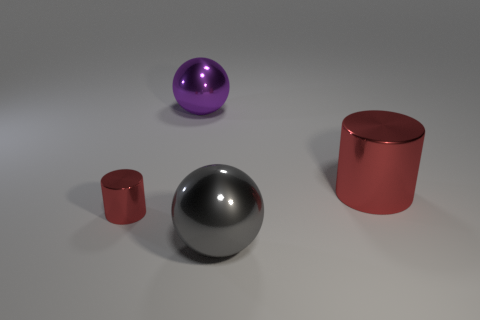What number of metallic balls are the same size as the gray object?
Offer a very short reply. 1. What size is the other metallic cylinder that is the same color as the tiny cylinder?
Provide a succinct answer. Large. What is the color of the metallic cylinder left of the large thing in front of the small red metal object?
Your answer should be very brief. Red. Are there any other metallic things of the same color as the small metal object?
Make the answer very short. Yes. There is a metal cylinder that is the same size as the purple metallic object; what color is it?
Your answer should be compact. Red. Do the red cylinder that is left of the purple ball and the gray thing have the same material?
Keep it short and to the point. Yes. There is a red cylinder on the left side of the red thing that is to the right of the big gray object; is there a purple shiny ball to the left of it?
Keep it short and to the point. No. There is a large shiny object that is on the left side of the big gray thing; does it have the same shape as the large gray thing?
Your answer should be compact. Yes. There is a red thing on the left side of the red metal cylinder right of the large gray ball; what shape is it?
Make the answer very short. Cylinder. There is a red shiny cylinder that is to the right of the big sphere that is in front of the large red cylinder that is behind the big gray shiny thing; how big is it?
Your answer should be very brief. Large. 